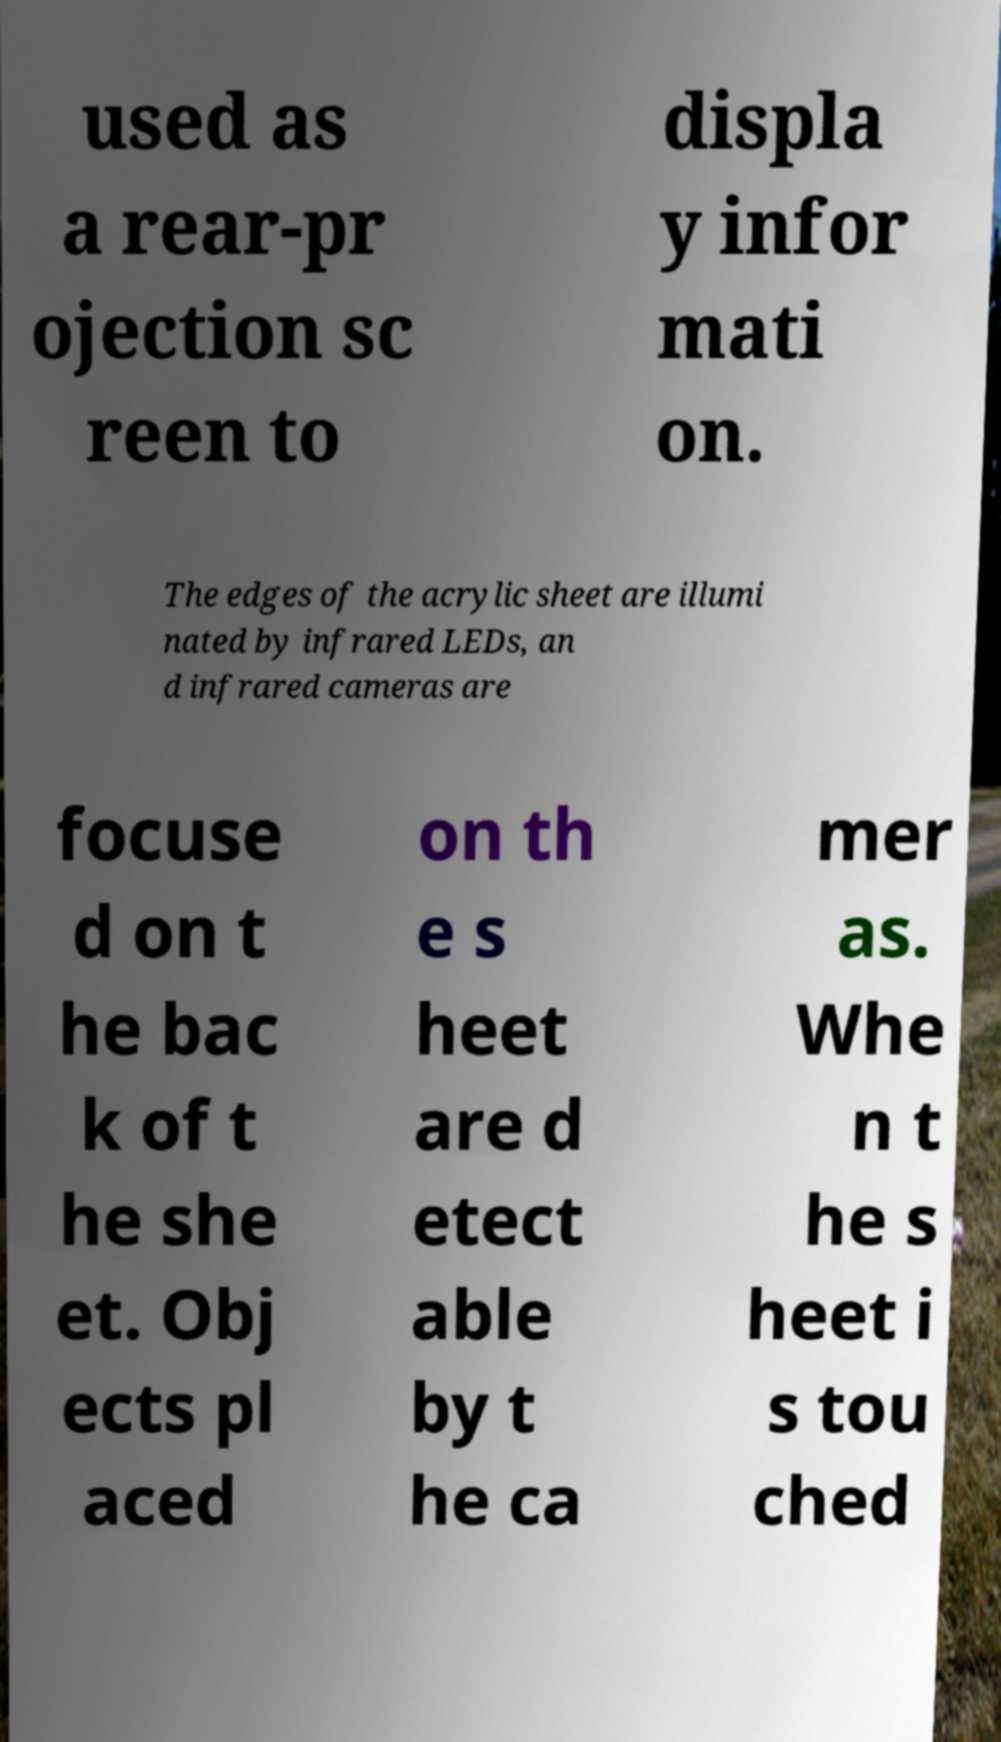What messages or text are displayed in this image? I need them in a readable, typed format. used as a rear-pr ojection sc reen to displa y infor mati on. The edges of the acrylic sheet are illumi nated by infrared LEDs, an d infrared cameras are focuse d on t he bac k of t he she et. Obj ects pl aced on th e s heet are d etect able by t he ca mer as. Whe n t he s heet i s tou ched 